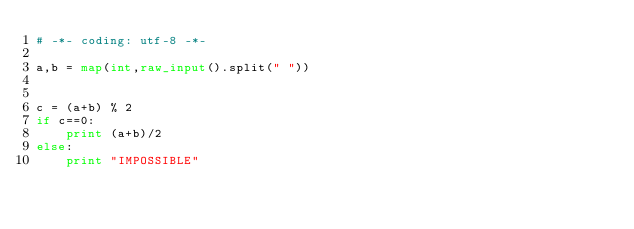Convert code to text. <code><loc_0><loc_0><loc_500><loc_500><_Python_># -*- coding: utf-8 -*-

a,b = map(int,raw_input().split(" "))


c = (a+b) % 2
if c==0:
    print (a+b)/2
else:
    print "IMPOSSIBLE"</code> 